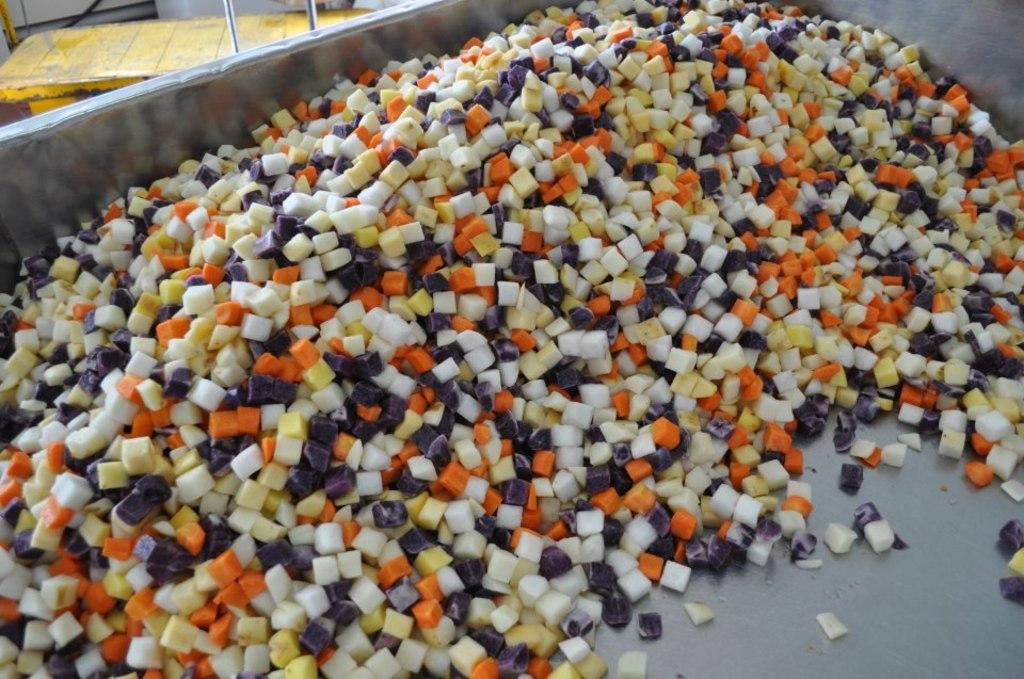What type of food can be seen in the image? The image contains colorful chopped vegetables. What type of container is the food placed in? The vegetables are placed in a steel container. Can you see a frog sitting on the vegetables in the image? There is no frog present in the image. What type of scale is used to measure the vegetables in the image? There is no scale present in the image, and the vegetables are not being measured. 